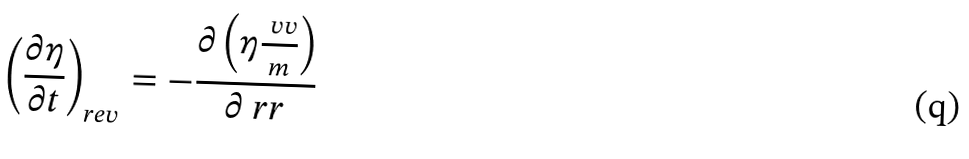<formula> <loc_0><loc_0><loc_500><loc_500>\left ( \frac { \partial \eta } { \partial t } \right ) _ { r e v } = - \frac { \partial \left ( \eta \frac { \ v v } { m } \right ) } { \partial \ r r }</formula> 